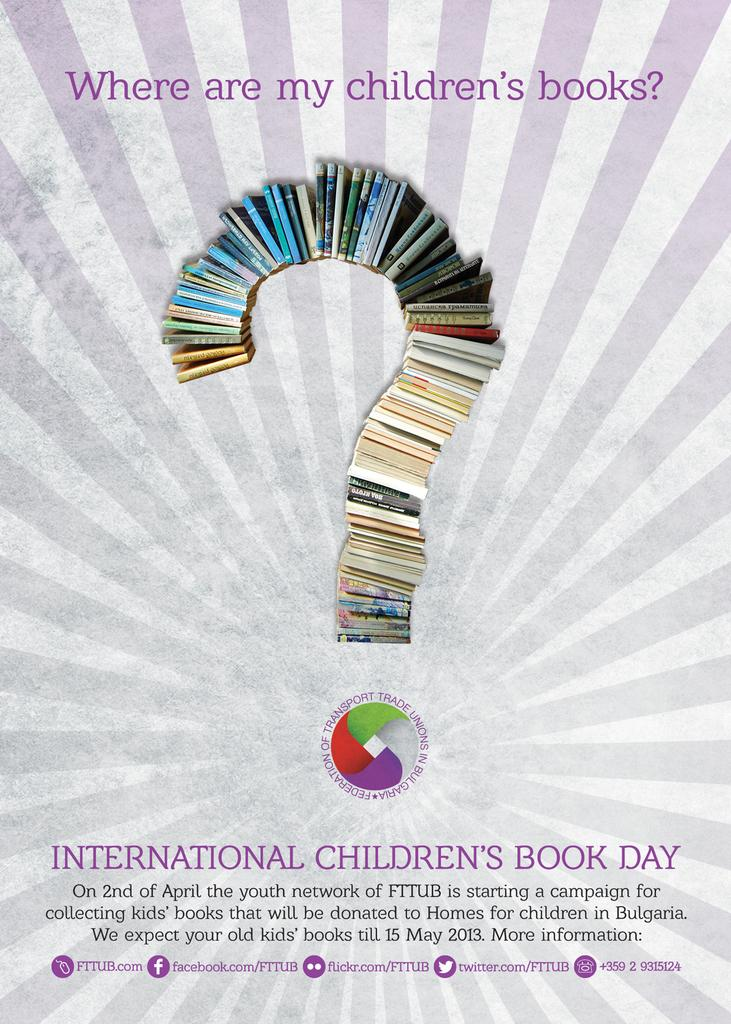Provide a one-sentence caption for the provided image. A poster of books in the shape of a question mark for the International Children's Book Day. 